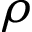<formula> <loc_0><loc_0><loc_500><loc_500>\rho</formula> 